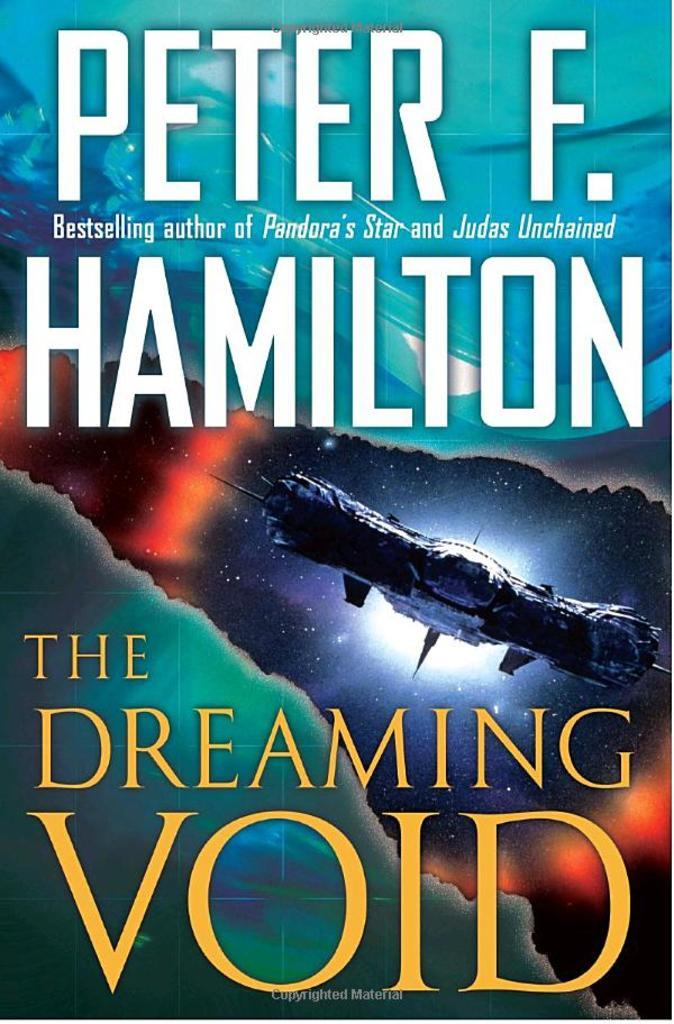<image>
Relay a brief, clear account of the picture shown. A poster of Peter F. Hamilton the Dreaming Void. 